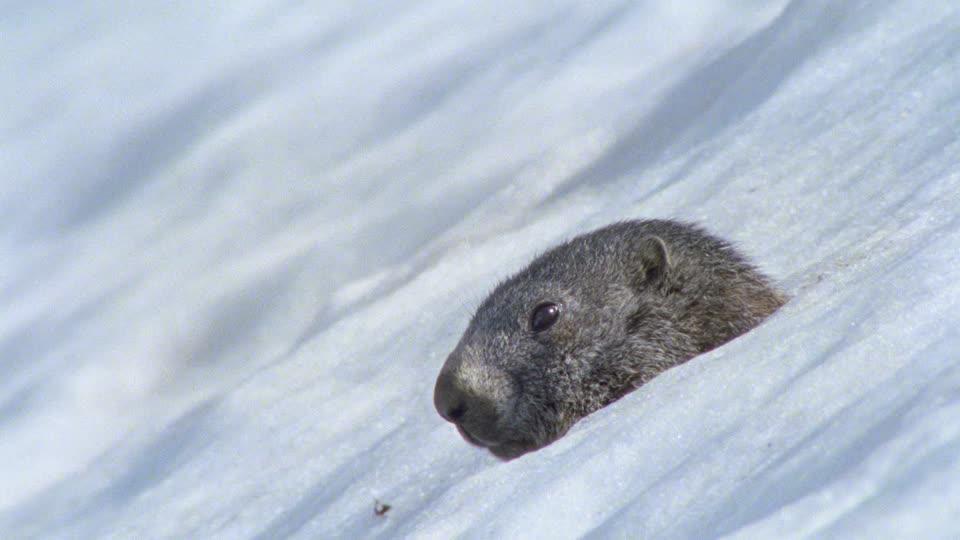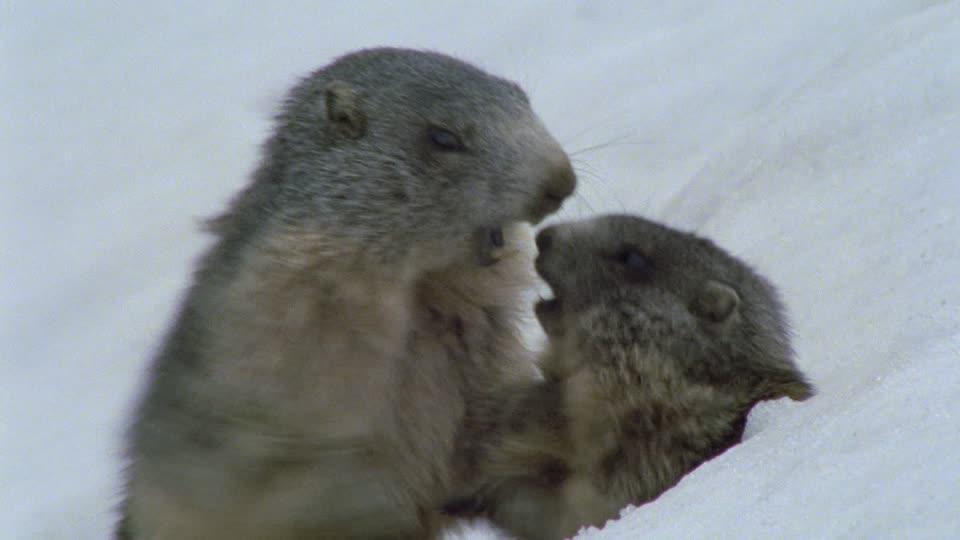The first image is the image on the left, the second image is the image on the right. Considering the images on both sides, is "One animal is in the snow in the image on the left." valid? Answer yes or no. Yes. The first image is the image on the left, the second image is the image on the right. Given the left and right images, does the statement "One image contains twice as many marmots as the other image." hold true? Answer yes or no. Yes. 